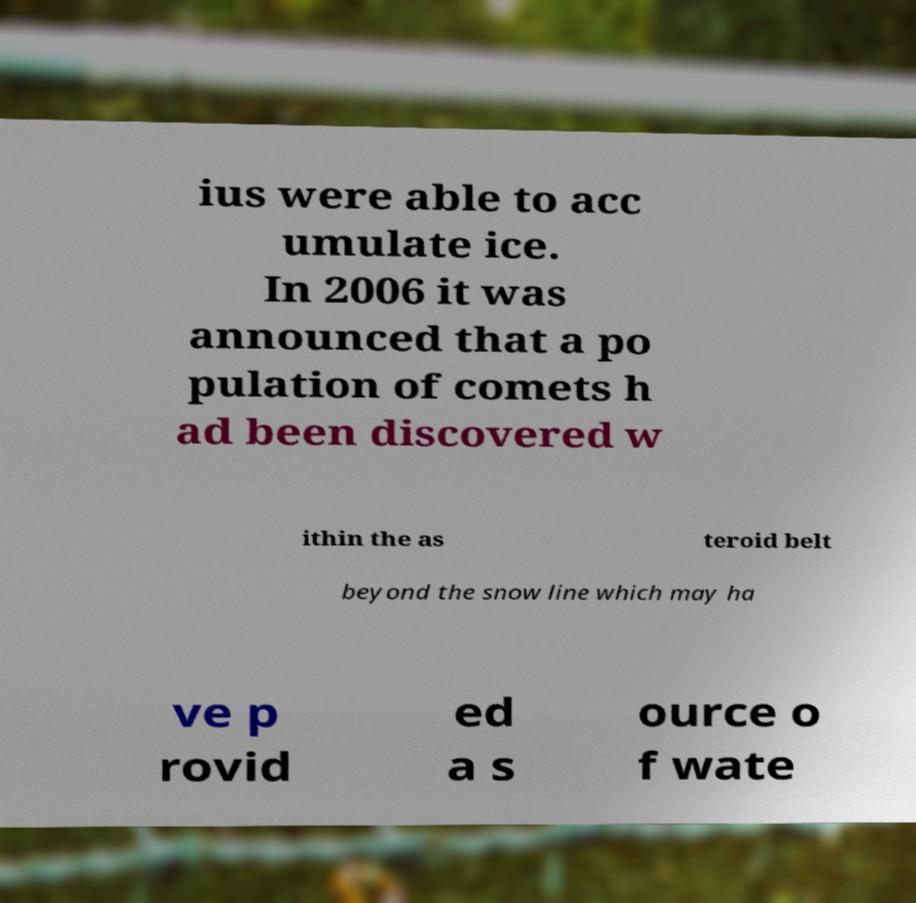Can you accurately transcribe the text from the provided image for me? ius were able to acc umulate ice. In 2006 it was announced that a po pulation of comets h ad been discovered w ithin the as teroid belt beyond the snow line which may ha ve p rovid ed a s ource o f wate 